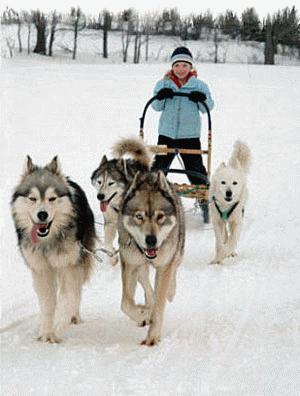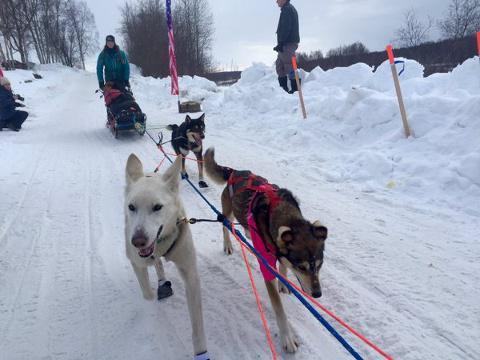The first image is the image on the left, the second image is the image on the right. Evaluate the accuracy of this statement regarding the images: "The right image contains no more than three dogs.". Is it true? Answer yes or no. Yes. 